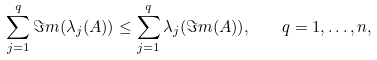<formula> <loc_0><loc_0><loc_500><loc_500>\sum _ { j = 1 } ^ { q } \Im m ( \lambda _ { j } ( A ) ) \leq \sum _ { j = 1 } ^ { q } \lambda _ { j } ( \Im m ( A ) ) , \quad q = 1 , \dots , n ,</formula> 